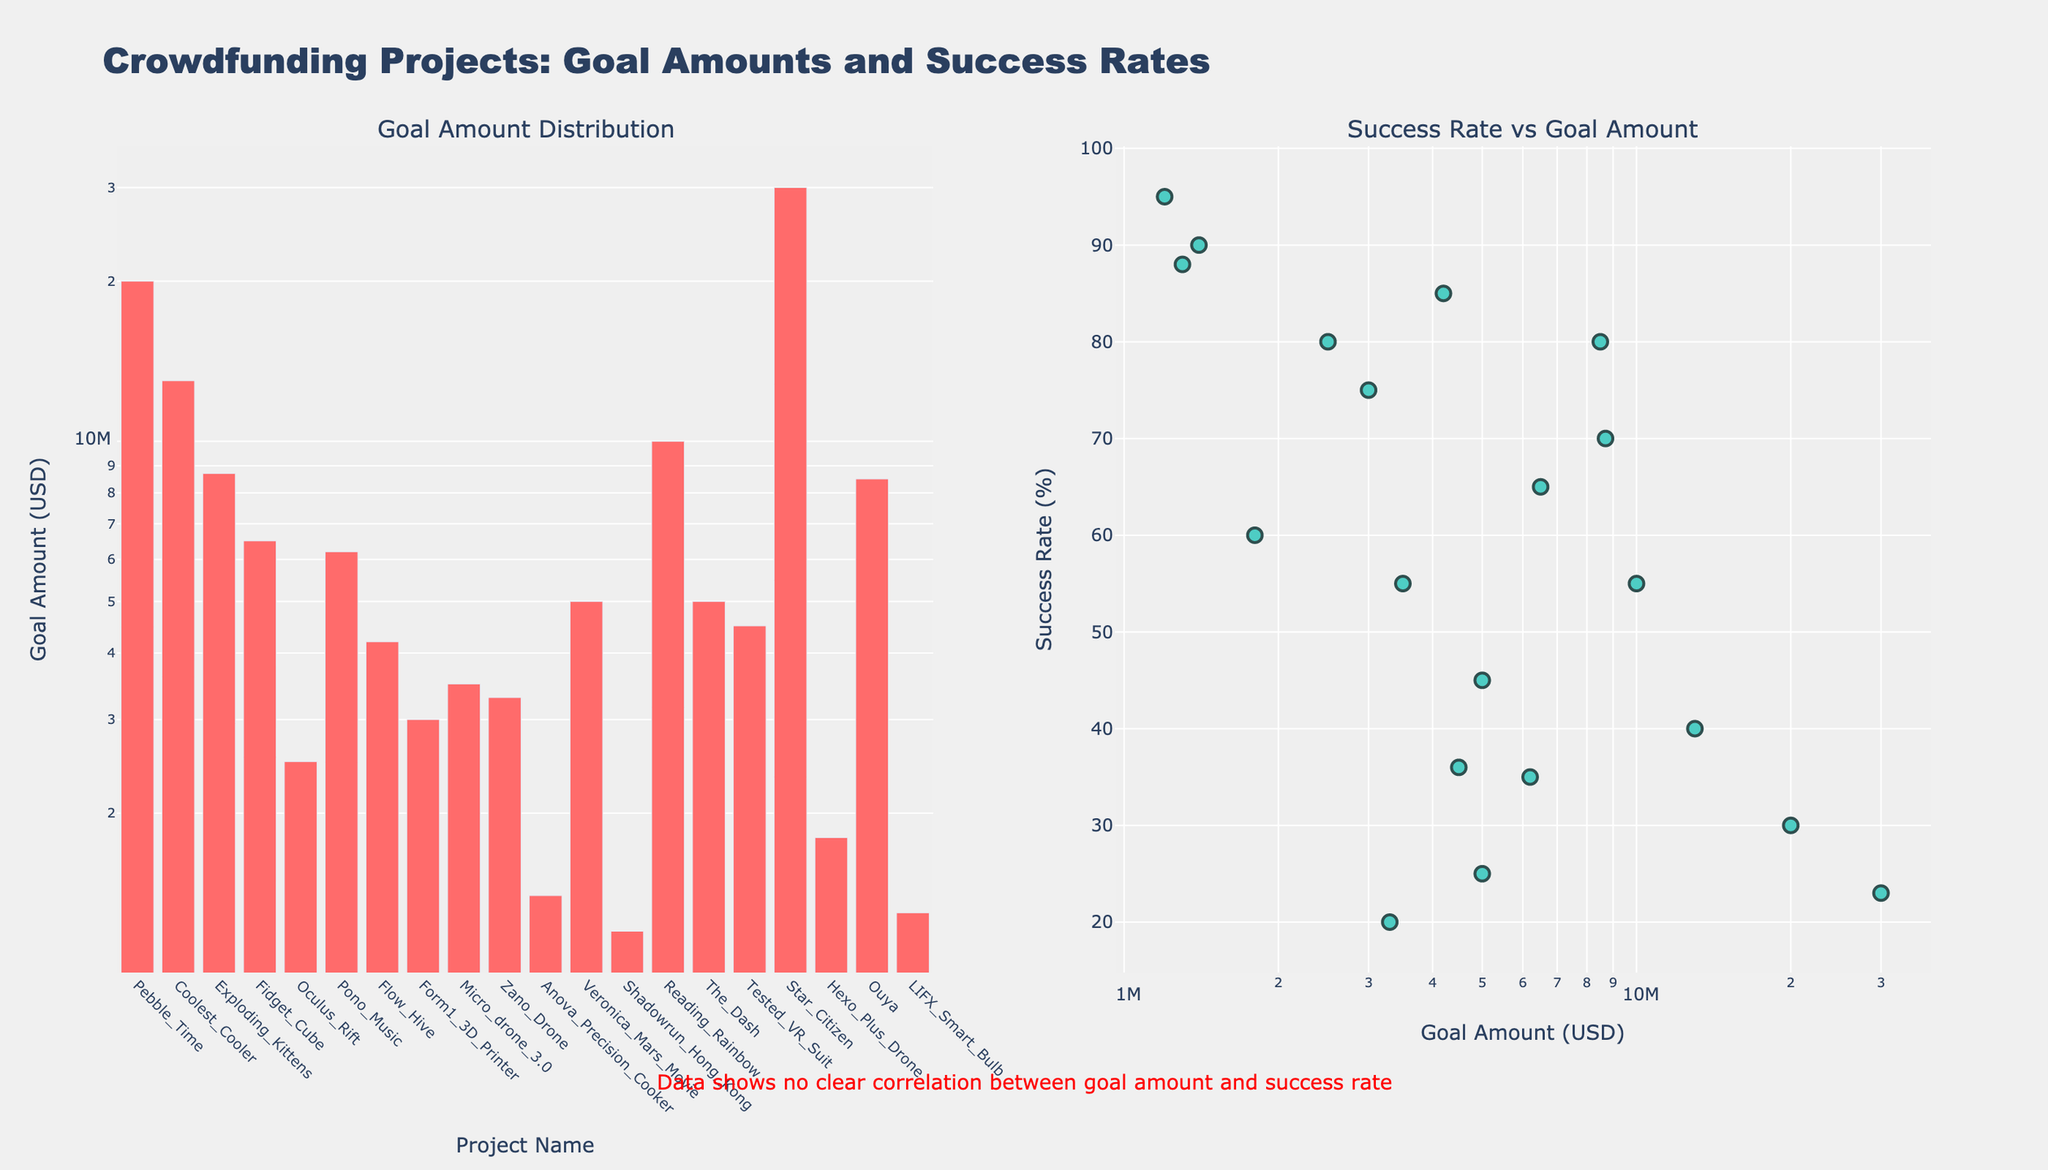What is the title of the figure? The title of the figure is located at the top center of the visual. It reads: 'Crowdfunding Projects: Goal Amounts and Success Rates'.
Answer: Crowdfunding Projects: Goal Amounts and Success Rates What are the axes titles in the subplot on the left? The x-axis title is 'Project Name', and the y-axis title is 'Goal Amount (USD)'. These titles are visible directly below the respective axes.
Answer: Project Name, Goal Amount (USD) How many crowdfunding projects are included in the figure? By counting the number of bars or markers, we can see that there are 20 projects in the figure.
Answer: 20 Which project has the highest goal amount, and what is its value? The subplot on the left shows the distribution of goal amounts. The tallest bar corresponds to the 'Star Citizen' project, and the goal amount is $30,000,000.
Answer: Star Citizen, $30,000,000 What is the success rate of the project with the smallest goal amount? On the right subplot, the smallest goal amount happens to be for 'Shadowrun Hong Kong' with $1,200,000. The corresponding success rate for it is 95%.
Answer: 95% Which project has the highest success rate, and what is its goal amount? On the right subplot, by identifying the marker at the highest point on the y-axis, 'Shadowrun Hong Kong' has the highest success rate of 95%, with a goal amount of $1,200,000.
Answer: Shadowrun Hong Kong, $1,200,000 What is the range of success rates across all projects? The success rates range from the lowest to the highest value on the right subplot's y-axis, which are 20% (for 'Zano Drone') to 95% (for 'Shadowrun Hong Kong').
Answer: 20% to 95% Do higher goal amounts generally correlate with higher success rates? By observing the right subplot, there is a spread of success rates across different goal amounts without a clear pattern, suggesting no strong correlation between goal amount and success rate.
Answer: No Which project has a goal amount of roughly $5,000,000, and what is its success rate? On the right subplot, 'Veronica Mars Movie' has a goal amount near $5,000,000 and its success rate is 45%. Another project, 'The Dash', also has a goal amount of $5,000,000 but with a success rate of 25%.
Answer: Veronica Mars Movie: 45%, The Dash: 25% Do any projects with goal amounts above $10,000,000 have a success rate above 50%? Observing the right subplot, we see that 'Pebble Time' at $20,000,000 (30%) and 'Coolest Cooler' at $13,000,000 (40%) do not meet this criteria. Only 'Exploding Kittens' at $8,700,000 with 70%, which is below $10,000,000, has a high success rate.
Answer: No 